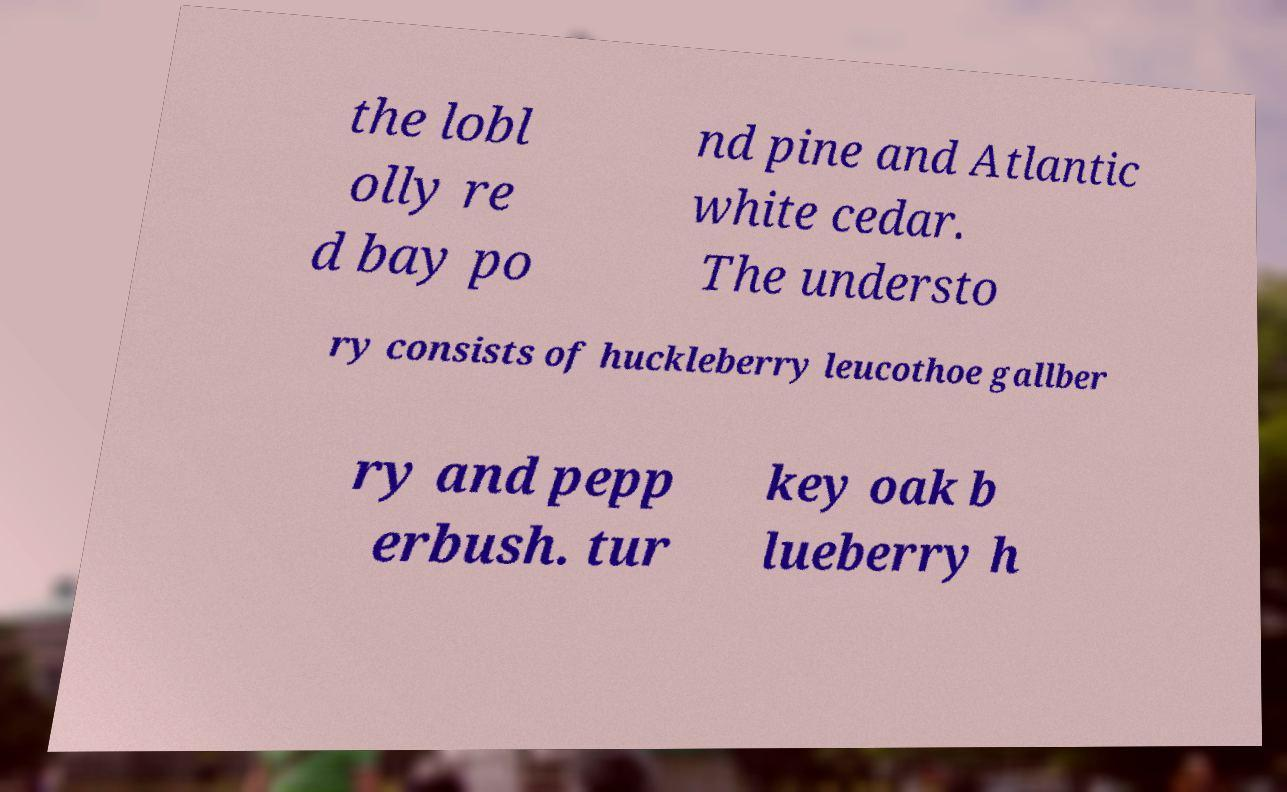For documentation purposes, I need the text within this image transcribed. Could you provide that? the lobl olly re d bay po nd pine and Atlantic white cedar. The understo ry consists of huckleberry leucothoe gallber ry and pepp erbush. tur key oak b lueberry h 